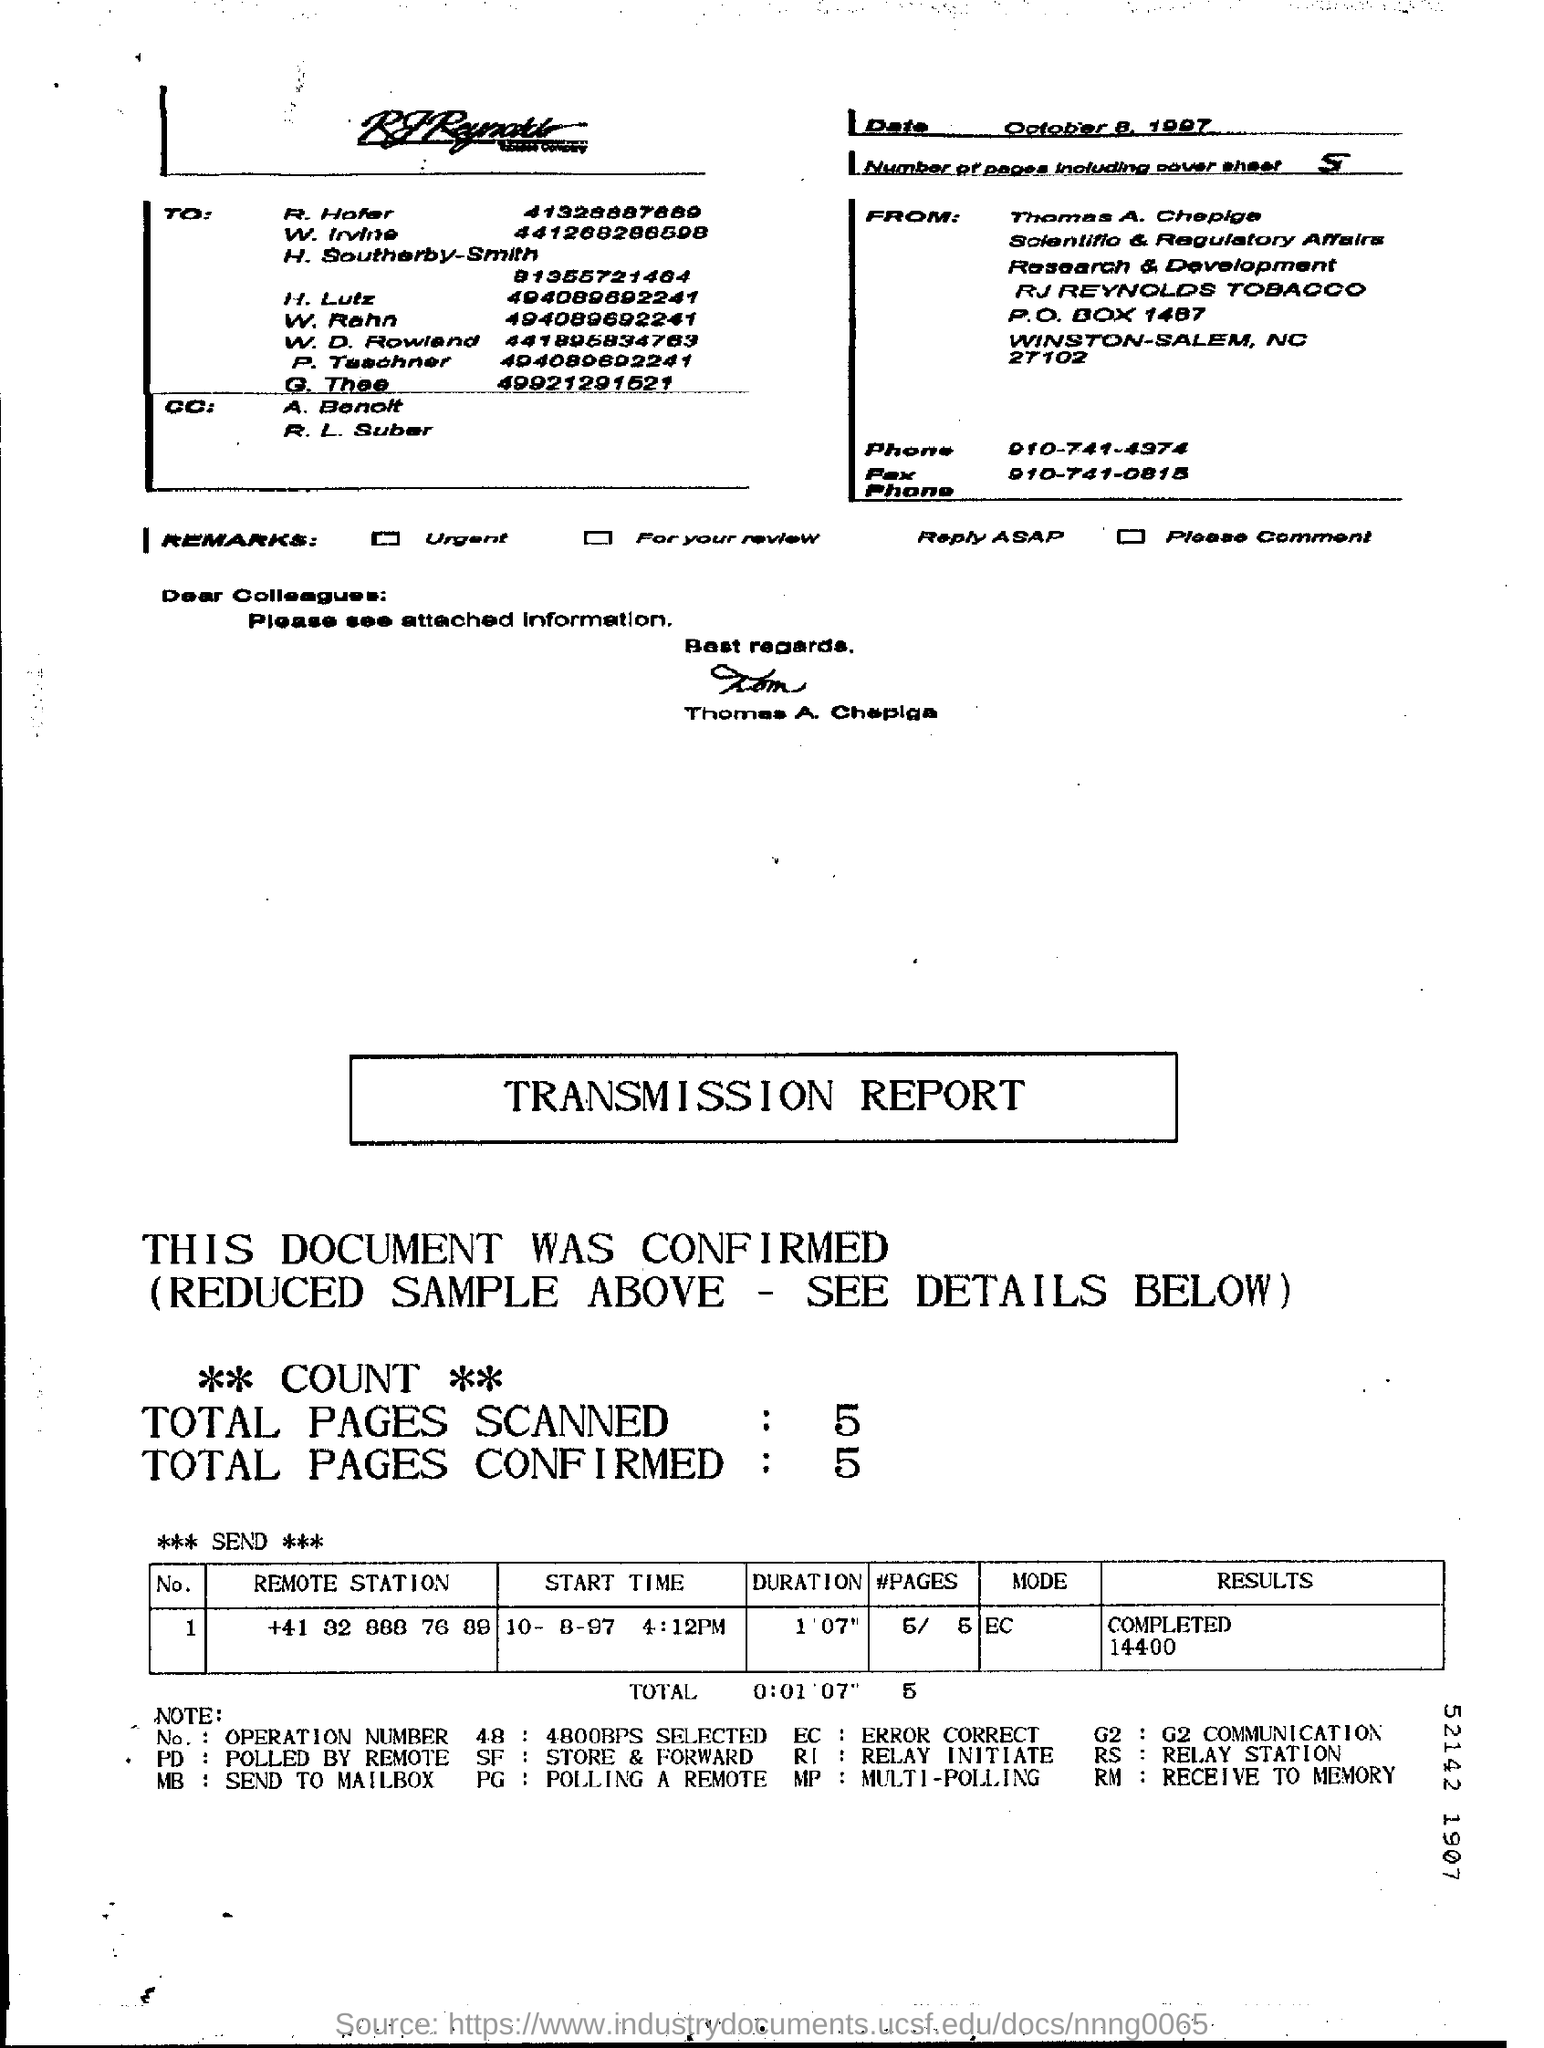What is the date mentioned in the page ?
Ensure brevity in your answer.  October  8, 1997. How many total pages are scanned in the transmission report ?
Ensure brevity in your answer.  5. How many total pages are confirmed in the transmission report ?
Provide a short and direct response. 5. What is the mode mentioned in the transmission report ?
Your response must be concise. EC. How many pages are there including cover sheet ?
Give a very brief answer. 5. 